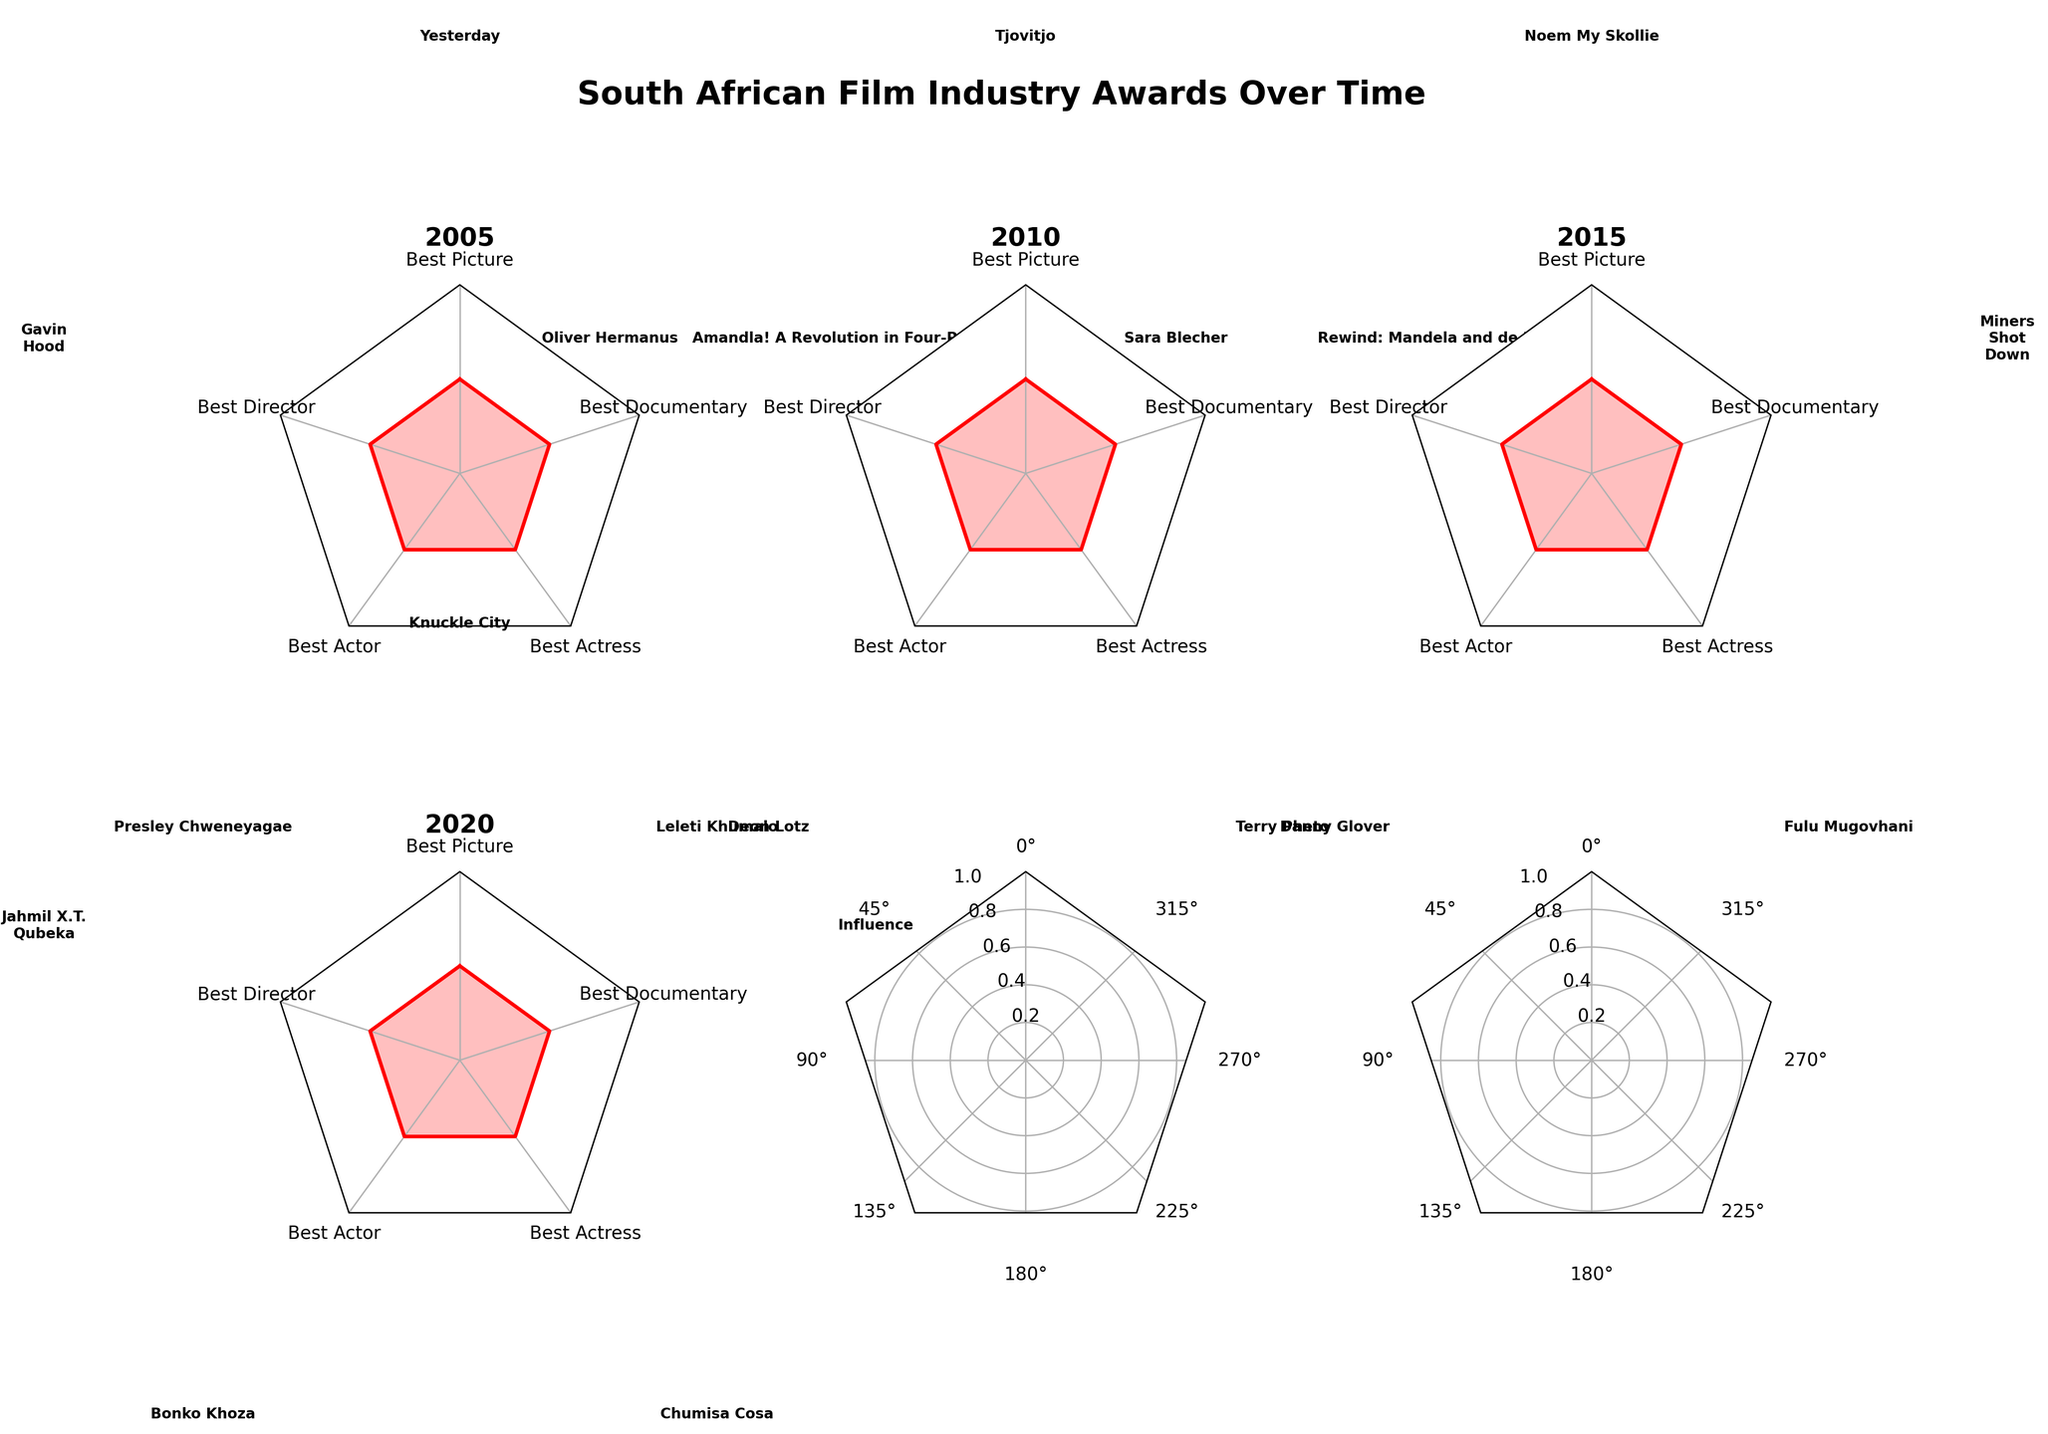what is the title of the figure? The title of the figure is usually located at the top of the chart in large, bold text. In this case, it can be directly read from the figure.
Answer: South African Film Industry Awards Over Time How many categories are shown in each subplot? By looking at each subplot, we can count the distinct labels set around the radial axis. There are five categories in total, namely "Best Picture," "Best Director," "Best Actor," "Best Actress," and "Best Documentary".
Answer: 5 Who won the Best Actress award in 2015? For each year, the award winners are annotated next to the category labels in each subplot. Looking at the 2015 subplot, we can see the annotation for the "Best Actress" category.
Answer: Fulu Mugovhani Which year did Presley Chweneyagae win the Best Actor award? By checking the annotations next to the "Best Actor" category in each subplot, we can identify the year Presley Chweneyagae was noted as the winner. This is found in the 2005 subplot.
Answer: 2005 Compare the winners of the Best Picture award in 2005 and 2020. By examining the annotations next to the "Best Picture" category in the 2005 and 2020 subplots, we observe the respective winners.
Answer: Yesterday (2005), Knuckle City (2020) Which category did Sara Blecher win in 2015 and in what role? Sara Blecher's name can be found annotated next to the relevant category in the 2015 subplot. She won the Best Director award in 2015.
Answer: Best Director How many different unique winners are shown for Best Documentary from 2005 to 2020? By reading the annotations next to the "Best Documentary" category in each year's subplot, we can list and count the unique winners. The winners are: Amandla! A Revolution in Four-Part Harmony (2005), Rewind: Mandela and de Klerk (2010), Miners Shot Down (2015), Influence (2020).
Answer: 4 What is the difference in winners between the Best Actor category in 2010 and 2020? By comparing the annotations for the "Best Actor" category in the 2010 and 2020 subplots, we identify the winners and note that they are different individuals. Deon Lotz won in 2010, and Bonko Khoza won in 2020.
Answer: Deon Lotz and Bonko Khoza 